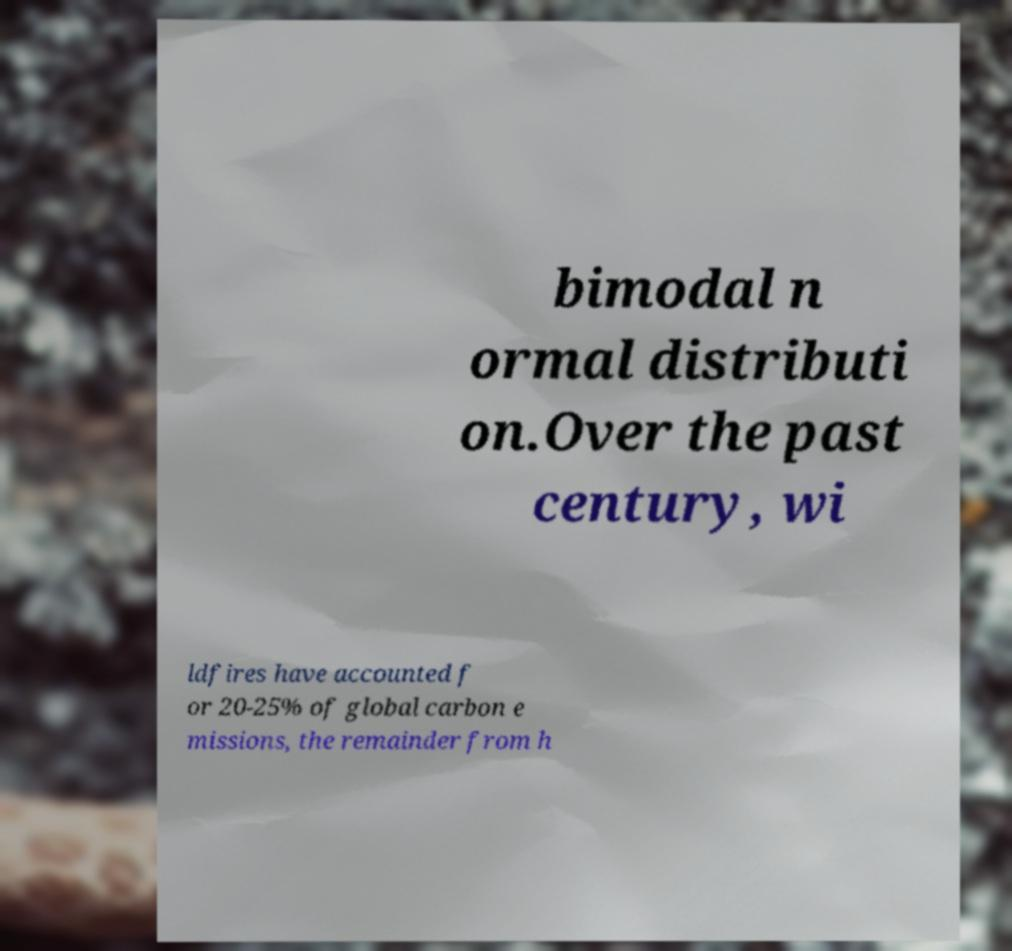For documentation purposes, I need the text within this image transcribed. Could you provide that? bimodal n ormal distributi on.Over the past century, wi ldfires have accounted f or 20-25% of global carbon e missions, the remainder from h 